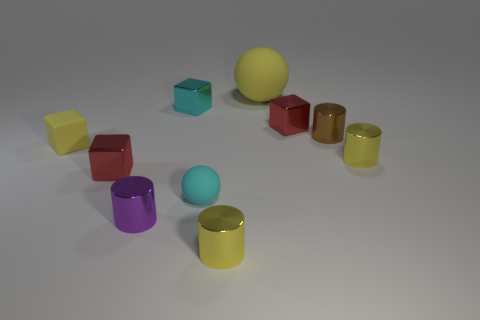How many metallic objects are yellow balls or spheres?
Keep it short and to the point. 0. There is a yellow cylinder behind the rubber sphere in front of the small yellow rubber cube; what is it made of?
Give a very brief answer. Metal. Are there more cyan spheres to the right of the cyan sphere than small yellow cubes?
Keep it short and to the point. No. Are there any large cylinders that have the same material as the tiny brown object?
Keep it short and to the point. No. There is a small red object to the left of the large matte sphere; is it the same shape as the cyan shiny thing?
Offer a very short reply. Yes. How many small yellow metallic objects are in front of the tiny red thing that is left of the yellow rubber object behind the cyan shiny block?
Your response must be concise. 1. Are there fewer cubes to the right of the brown object than purple shiny cylinders that are behind the large yellow matte thing?
Your response must be concise. No. There is another rubber object that is the same shape as the cyan rubber object; what color is it?
Give a very brief answer. Yellow. The cyan shiny thing has what size?
Your response must be concise. Small. What number of other cyan cubes have the same size as the cyan block?
Your response must be concise. 0. 